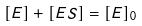Convert formula to latex. <formula><loc_0><loc_0><loc_500><loc_500>[ E ] + [ E S ] = [ E ] _ { 0 }</formula> 